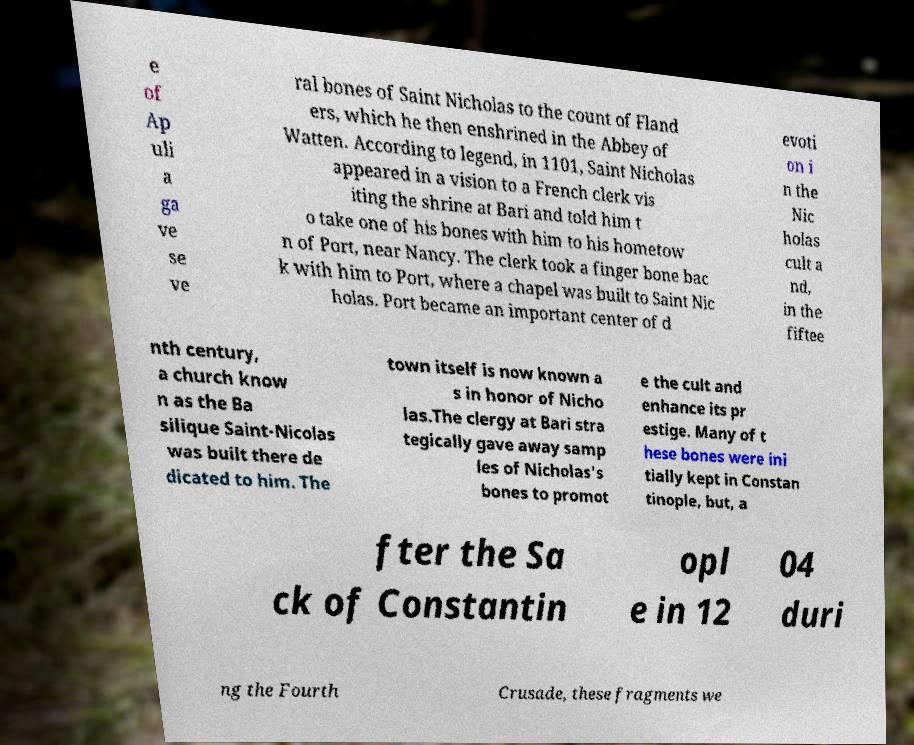Please identify and transcribe the text found in this image. e of Ap uli a ga ve se ve ral bones of Saint Nicholas to the count of Fland ers, which he then enshrined in the Abbey of Watten. According to legend, in 1101, Saint Nicholas appeared in a vision to a French clerk vis iting the shrine at Bari and told him t o take one of his bones with him to his hometow n of Port, near Nancy. The clerk took a finger bone bac k with him to Port, where a chapel was built to Saint Nic holas. Port became an important center of d evoti on i n the Nic holas cult a nd, in the fiftee nth century, a church know n as the Ba silique Saint-Nicolas was built there de dicated to him. The town itself is now known a s in honor of Nicho las.The clergy at Bari stra tegically gave away samp les of Nicholas's bones to promot e the cult and enhance its pr estige. Many of t hese bones were ini tially kept in Constan tinople, but, a fter the Sa ck of Constantin opl e in 12 04 duri ng the Fourth Crusade, these fragments we 